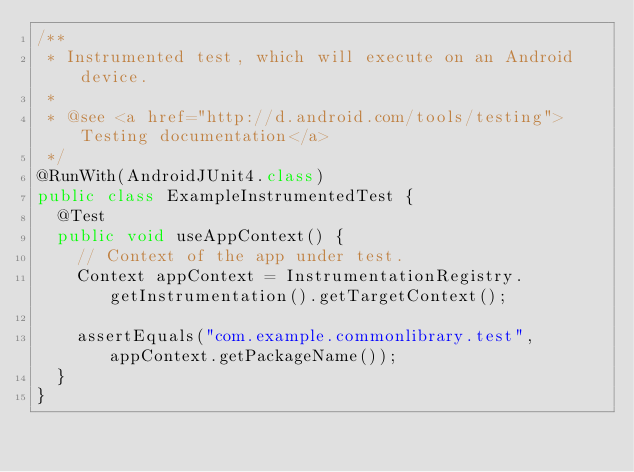<code> <loc_0><loc_0><loc_500><loc_500><_Java_>/**
 * Instrumented test, which will execute on an Android device.
 *
 * @see <a href="http://d.android.com/tools/testing">Testing documentation</a>
 */
@RunWith(AndroidJUnit4.class)
public class ExampleInstrumentedTest {
  @Test
  public void useAppContext() {
    // Context of the app under test.
    Context appContext = InstrumentationRegistry.getInstrumentation().getTargetContext();

    assertEquals("com.example.commonlibrary.test", appContext.getPackageName());
  }
}
</code> 